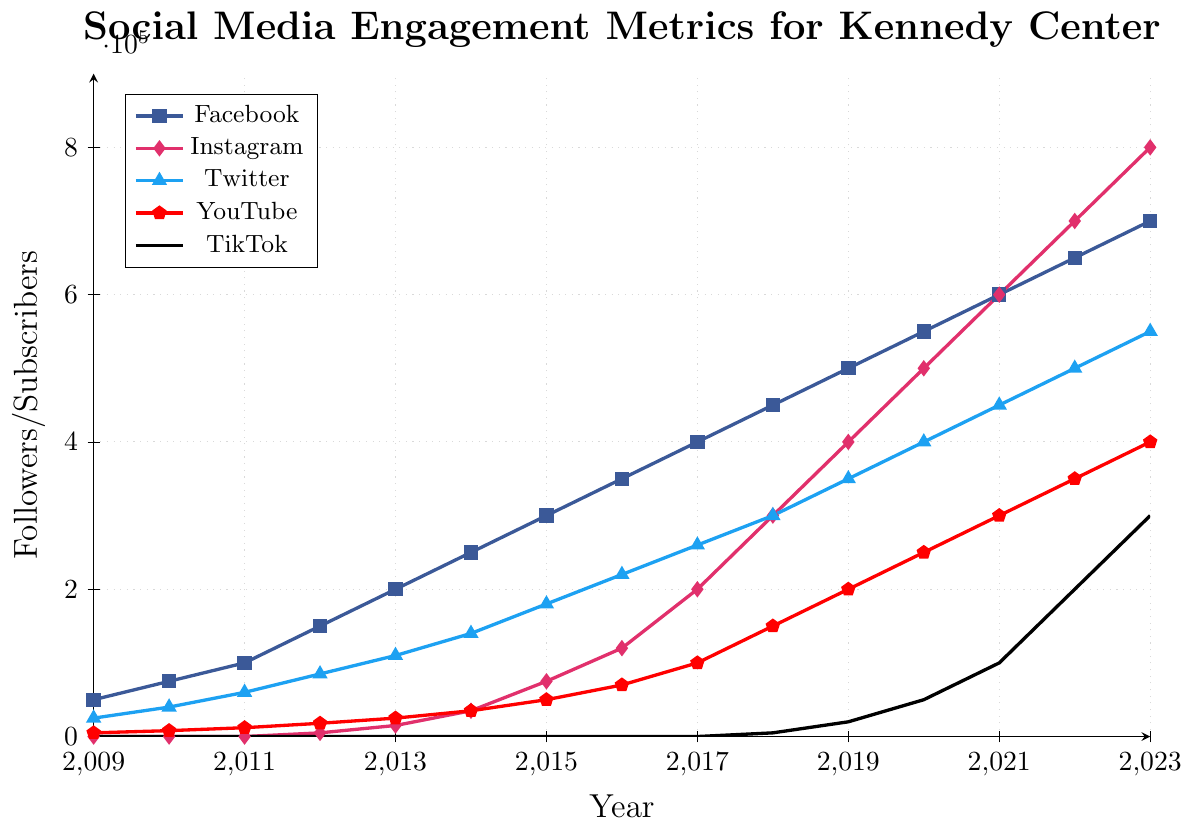Which platform had the highest number of followers in 2023? From the figure, locate the highest point in 2023 among all platforms' lines. Instagram's line reaches 800,000, which is the highest.
Answer: Instagram By how much did YouTube subscribers increase from 2009 to 2023? Identify the number of YouTube subscribers in 2009 and 2023 from the figure. In 2009, there are 5,000 subscribers, and in 2023, there are 400,000 subscribers. The increase is 400,000 - 5,000.
Answer: 395,000 Which platform showed the most growth between 2018 and 2023? Compare the follower counts for each platform between 2018 and 2023. Instagram had the largest increase from 300,000 in 2018 to 800,000 in 2023, a growth of 500,000.
Answer: Instagram Were there any platforms that did not exist before a certain year? If yes, which ones? From the figure, observe that TikTok and Instagram lines start later than other platforms, with TikTok starting in 2018 and Instagram in 2012.
Answer: TikTok and Instagram What was the total number of followers across all platforms in 2023? Sum the follower counts for all platforms in 2023: 700,000 (Facebook) + 800,000 (Instagram) + 550,000 (Twitter) + 400,000 (YouTube) + 300,000 (TikTok).
Answer: 2,750,000 Compare the growth rates of Facebook and Twitter from their inception to 2023. Which grew faster? Calculate the growth for both platforms: Facebook grew from 50,000 in 2009 to 700,000 in 2023, a growth of 650,000. Twitter grew from 25,000 in 2009 to 550,000 in 2023, a growth of 525,000. Facebook had a higher growth rate.
Answer: Facebook Identify all platforms that saw a steady increase in followers/subscribers each year. From the visual trend of each line in the figure, observe that Facebook, Twitter, and YouTube lines exhibit a consistent upward trajectory without any decreases or plateaus.
Answer: Facebook, Twitter, YouTube What is the average number of Instagram followers in the last five years (2019-2023)? Locate Instagram follower counts for 2019-2023: 400,000, 500,000, 600,000, 700,000, and 800,000. Calculate the average: (400,000 + 500,000 + 600,000 + 700,000 + 800,000)/5.
Answer: 600,000 Which platform had the least number of followers in 2012? Observe from the figure that in 2012, TikTok and Instagram had very low numbers (zero and 5,000 respectively), with TikTok having the least with zero followers.
Answer: TikTok 